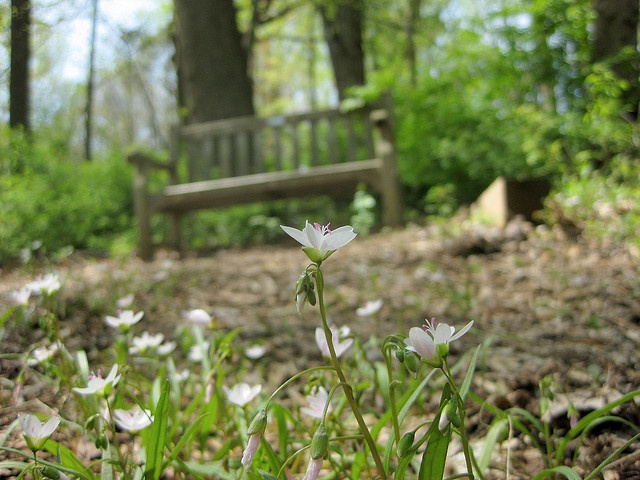Describe the objects in this image and their specific colors. I can see a bench in lightgray, darkgreen, gray, and olive tones in this image. 